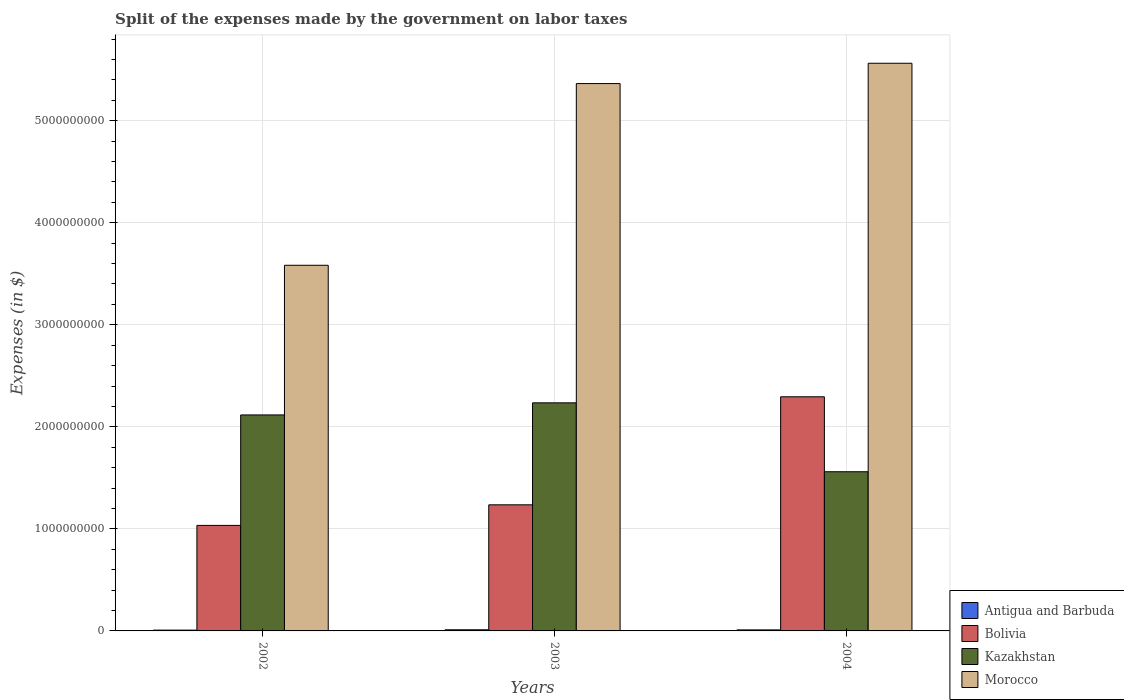Are the number of bars on each tick of the X-axis equal?
Keep it short and to the point. Yes. How many bars are there on the 2nd tick from the left?
Your response must be concise. 4. What is the label of the 3rd group of bars from the left?
Your answer should be very brief. 2004. In how many cases, is the number of bars for a given year not equal to the number of legend labels?
Give a very brief answer. 0. What is the expenses made by the government on labor taxes in Bolivia in 2003?
Offer a very short reply. 1.24e+09. Across all years, what is the maximum expenses made by the government on labor taxes in Bolivia?
Give a very brief answer. 2.29e+09. Across all years, what is the minimum expenses made by the government on labor taxes in Antigua and Barbuda?
Your answer should be very brief. 7.90e+06. In which year was the expenses made by the government on labor taxes in Morocco maximum?
Offer a very short reply. 2004. What is the total expenses made by the government on labor taxes in Antigua and Barbuda in the graph?
Offer a very short reply. 2.90e+07. What is the difference between the expenses made by the government on labor taxes in Antigua and Barbuda in 2002 and that in 2003?
Your answer should be compact. -3.20e+06. What is the difference between the expenses made by the government on labor taxes in Morocco in 2003 and the expenses made by the government on labor taxes in Antigua and Barbuda in 2002?
Keep it short and to the point. 5.36e+09. What is the average expenses made by the government on labor taxes in Kazakhstan per year?
Keep it short and to the point. 1.97e+09. In the year 2003, what is the difference between the expenses made by the government on labor taxes in Kazakhstan and expenses made by the government on labor taxes in Morocco?
Offer a very short reply. -3.13e+09. In how many years, is the expenses made by the government on labor taxes in Morocco greater than 1200000000 $?
Make the answer very short. 3. What is the ratio of the expenses made by the government on labor taxes in Antigua and Barbuda in 2002 to that in 2004?
Keep it short and to the point. 0.79. Is the expenses made by the government on labor taxes in Morocco in 2002 less than that in 2003?
Make the answer very short. Yes. Is the difference between the expenses made by the government on labor taxes in Kazakhstan in 2002 and 2004 greater than the difference between the expenses made by the government on labor taxes in Morocco in 2002 and 2004?
Keep it short and to the point. Yes. What is the difference between the highest and the second highest expenses made by the government on labor taxes in Morocco?
Your answer should be very brief. 1.99e+08. What is the difference between the highest and the lowest expenses made by the government on labor taxes in Antigua and Barbuda?
Offer a terse response. 3.20e+06. Is the sum of the expenses made by the government on labor taxes in Bolivia in 2002 and 2003 greater than the maximum expenses made by the government on labor taxes in Kazakhstan across all years?
Your response must be concise. Yes. Is it the case that in every year, the sum of the expenses made by the government on labor taxes in Antigua and Barbuda and expenses made by the government on labor taxes in Kazakhstan is greater than the sum of expenses made by the government on labor taxes in Morocco and expenses made by the government on labor taxes in Bolivia?
Keep it short and to the point. No. How many bars are there?
Keep it short and to the point. 12. Are all the bars in the graph horizontal?
Your answer should be very brief. No. How many years are there in the graph?
Give a very brief answer. 3. Where does the legend appear in the graph?
Provide a short and direct response. Bottom right. What is the title of the graph?
Give a very brief answer. Split of the expenses made by the government on labor taxes. What is the label or title of the Y-axis?
Your response must be concise. Expenses (in $). What is the Expenses (in $) in Antigua and Barbuda in 2002?
Your answer should be compact. 7.90e+06. What is the Expenses (in $) of Bolivia in 2002?
Your answer should be compact. 1.03e+09. What is the Expenses (in $) of Kazakhstan in 2002?
Provide a succinct answer. 2.12e+09. What is the Expenses (in $) in Morocco in 2002?
Your answer should be compact. 3.58e+09. What is the Expenses (in $) of Antigua and Barbuda in 2003?
Your answer should be compact. 1.11e+07. What is the Expenses (in $) of Bolivia in 2003?
Your response must be concise. 1.24e+09. What is the Expenses (in $) in Kazakhstan in 2003?
Provide a succinct answer. 2.24e+09. What is the Expenses (in $) of Morocco in 2003?
Provide a short and direct response. 5.36e+09. What is the Expenses (in $) of Antigua and Barbuda in 2004?
Give a very brief answer. 1.00e+07. What is the Expenses (in $) in Bolivia in 2004?
Offer a terse response. 2.29e+09. What is the Expenses (in $) of Kazakhstan in 2004?
Keep it short and to the point. 1.56e+09. What is the Expenses (in $) of Morocco in 2004?
Your response must be concise. 5.56e+09. Across all years, what is the maximum Expenses (in $) in Antigua and Barbuda?
Ensure brevity in your answer.  1.11e+07. Across all years, what is the maximum Expenses (in $) of Bolivia?
Your answer should be compact. 2.29e+09. Across all years, what is the maximum Expenses (in $) in Kazakhstan?
Provide a succinct answer. 2.24e+09. Across all years, what is the maximum Expenses (in $) of Morocco?
Give a very brief answer. 5.56e+09. Across all years, what is the minimum Expenses (in $) of Antigua and Barbuda?
Offer a terse response. 7.90e+06. Across all years, what is the minimum Expenses (in $) of Bolivia?
Your response must be concise. 1.03e+09. Across all years, what is the minimum Expenses (in $) of Kazakhstan?
Keep it short and to the point. 1.56e+09. Across all years, what is the minimum Expenses (in $) of Morocco?
Keep it short and to the point. 3.58e+09. What is the total Expenses (in $) of Antigua and Barbuda in the graph?
Your response must be concise. 2.90e+07. What is the total Expenses (in $) in Bolivia in the graph?
Keep it short and to the point. 4.56e+09. What is the total Expenses (in $) of Kazakhstan in the graph?
Provide a short and direct response. 5.91e+09. What is the total Expenses (in $) of Morocco in the graph?
Offer a terse response. 1.45e+1. What is the difference between the Expenses (in $) in Antigua and Barbuda in 2002 and that in 2003?
Provide a succinct answer. -3.20e+06. What is the difference between the Expenses (in $) in Bolivia in 2002 and that in 2003?
Provide a succinct answer. -2.02e+08. What is the difference between the Expenses (in $) in Kazakhstan in 2002 and that in 2003?
Keep it short and to the point. -1.19e+08. What is the difference between the Expenses (in $) in Morocco in 2002 and that in 2003?
Your answer should be very brief. -1.78e+09. What is the difference between the Expenses (in $) of Antigua and Barbuda in 2002 and that in 2004?
Keep it short and to the point. -2.10e+06. What is the difference between the Expenses (in $) of Bolivia in 2002 and that in 2004?
Offer a terse response. -1.26e+09. What is the difference between the Expenses (in $) in Kazakhstan in 2002 and that in 2004?
Ensure brevity in your answer.  5.57e+08. What is the difference between the Expenses (in $) in Morocco in 2002 and that in 2004?
Give a very brief answer. -1.98e+09. What is the difference between the Expenses (in $) in Antigua and Barbuda in 2003 and that in 2004?
Provide a succinct answer. 1.10e+06. What is the difference between the Expenses (in $) of Bolivia in 2003 and that in 2004?
Give a very brief answer. -1.06e+09. What is the difference between the Expenses (in $) in Kazakhstan in 2003 and that in 2004?
Give a very brief answer. 6.75e+08. What is the difference between the Expenses (in $) in Morocco in 2003 and that in 2004?
Ensure brevity in your answer.  -1.99e+08. What is the difference between the Expenses (in $) of Antigua and Barbuda in 2002 and the Expenses (in $) of Bolivia in 2003?
Offer a very short reply. -1.23e+09. What is the difference between the Expenses (in $) of Antigua and Barbuda in 2002 and the Expenses (in $) of Kazakhstan in 2003?
Offer a very short reply. -2.23e+09. What is the difference between the Expenses (in $) of Antigua and Barbuda in 2002 and the Expenses (in $) of Morocco in 2003?
Provide a succinct answer. -5.36e+09. What is the difference between the Expenses (in $) of Bolivia in 2002 and the Expenses (in $) of Kazakhstan in 2003?
Provide a short and direct response. -1.20e+09. What is the difference between the Expenses (in $) of Bolivia in 2002 and the Expenses (in $) of Morocco in 2003?
Your response must be concise. -4.33e+09. What is the difference between the Expenses (in $) in Kazakhstan in 2002 and the Expenses (in $) in Morocco in 2003?
Make the answer very short. -3.25e+09. What is the difference between the Expenses (in $) of Antigua and Barbuda in 2002 and the Expenses (in $) of Bolivia in 2004?
Provide a short and direct response. -2.29e+09. What is the difference between the Expenses (in $) of Antigua and Barbuda in 2002 and the Expenses (in $) of Kazakhstan in 2004?
Keep it short and to the point. -1.55e+09. What is the difference between the Expenses (in $) of Antigua and Barbuda in 2002 and the Expenses (in $) of Morocco in 2004?
Ensure brevity in your answer.  -5.56e+09. What is the difference between the Expenses (in $) of Bolivia in 2002 and the Expenses (in $) of Kazakhstan in 2004?
Provide a short and direct response. -5.26e+08. What is the difference between the Expenses (in $) of Bolivia in 2002 and the Expenses (in $) of Morocco in 2004?
Keep it short and to the point. -4.53e+09. What is the difference between the Expenses (in $) in Kazakhstan in 2002 and the Expenses (in $) in Morocco in 2004?
Give a very brief answer. -3.45e+09. What is the difference between the Expenses (in $) of Antigua and Barbuda in 2003 and the Expenses (in $) of Bolivia in 2004?
Provide a succinct answer. -2.28e+09. What is the difference between the Expenses (in $) of Antigua and Barbuda in 2003 and the Expenses (in $) of Kazakhstan in 2004?
Your answer should be compact. -1.55e+09. What is the difference between the Expenses (in $) in Antigua and Barbuda in 2003 and the Expenses (in $) in Morocco in 2004?
Your answer should be compact. -5.55e+09. What is the difference between the Expenses (in $) in Bolivia in 2003 and the Expenses (in $) in Kazakhstan in 2004?
Keep it short and to the point. -3.24e+08. What is the difference between the Expenses (in $) of Bolivia in 2003 and the Expenses (in $) of Morocco in 2004?
Give a very brief answer. -4.33e+09. What is the difference between the Expenses (in $) in Kazakhstan in 2003 and the Expenses (in $) in Morocco in 2004?
Your answer should be very brief. -3.33e+09. What is the average Expenses (in $) in Antigua and Barbuda per year?
Your response must be concise. 9.67e+06. What is the average Expenses (in $) in Bolivia per year?
Provide a short and direct response. 1.52e+09. What is the average Expenses (in $) in Kazakhstan per year?
Give a very brief answer. 1.97e+09. What is the average Expenses (in $) in Morocco per year?
Your response must be concise. 4.84e+09. In the year 2002, what is the difference between the Expenses (in $) in Antigua and Barbuda and Expenses (in $) in Bolivia?
Your answer should be compact. -1.03e+09. In the year 2002, what is the difference between the Expenses (in $) of Antigua and Barbuda and Expenses (in $) of Kazakhstan?
Provide a succinct answer. -2.11e+09. In the year 2002, what is the difference between the Expenses (in $) of Antigua and Barbuda and Expenses (in $) of Morocco?
Your answer should be compact. -3.58e+09. In the year 2002, what is the difference between the Expenses (in $) of Bolivia and Expenses (in $) of Kazakhstan?
Ensure brevity in your answer.  -1.08e+09. In the year 2002, what is the difference between the Expenses (in $) of Bolivia and Expenses (in $) of Morocco?
Your answer should be very brief. -2.55e+09. In the year 2002, what is the difference between the Expenses (in $) of Kazakhstan and Expenses (in $) of Morocco?
Give a very brief answer. -1.47e+09. In the year 2003, what is the difference between the Expenses (in $) in Antigua and Barbuda and Expenses (in $) in Bolivia?
Your answer should be very brief. -1.22e+09. In the year 2003, what is the difference between the Expenses (in $) in Antigua and Barbuda and Expenses (in $) in Kazakhstan?
Give a very brief answer. -2.22e+09. In the year 2003, what is the difference between the Expenses (in $) of Antigua and Barbuda and Expenses (in $) of Morocco?
Give a very brief answer. -5.35e+09. In the year 2003, what is the difference between the Expenses (in $) of Bolivia and Expenses (in $) of Kazakhstan?
Provide a short and direct response. -9.99e+08. In the year 2003, what is the difference between the Expenses (in $) in Bolivia and Expenses (in $) in Morocco?
Make the answer very short. -4.13e+09. In the year 2003, what is the difference between the Expenses (in $) of Kazakhstan and Expenses (in $) of Morocco?
Give a very brief answer. -3.13e+09. In the year 2004, what is the difference between the Expenses (in $) in Antigua and Barbuda and Expenses (in $) in Bolivia?
Provide a short and direct response. -2.28e+09. In the year 2004, what is the difference between the Expenses (in $) in Antigua and Barbuda and Expenses (in $) in Kazakhstan?
Offer a terse response. -1.55e+09. In the year 2004, what is the difference between the Expenses (in $) in Antigua and Barbuda and Expenses (in $) in Morocco?
Your answer should be very brief. -5.55e+09. In the year 2004, what is the difference between the Expenses (in $) of Bolivia and Expenses (in $) of Kazakhstan?
Ensure brevity in your answer.  7.35e+08. In the year 2004, what is the difference between the Expenses (in $) in Bolivia and Expenses (in $) in Morocco?
Your answer should be very brief. -3.27e+09. In the year 2004, what is the difference between the Expenses (in $) of Kazakhstan and Expenses (in $) of Morocco?
Ensure brevity in your answer.  -4.00e+09. What is the ratio of the Expenses (in $) in Antigua and Barbuda in 2002 to that in 2003?
Keep it short and to the point. 0.71. What is the ratio of the Expenses (in $) in Bolivia in 2002 to that in 2003?
Provide a short and direct response. 0.84. What is the ratio of the Expenses (in $) of Kazakhstan in 2002 to that in 2003?
Provide a succinct answer. 0.95. What is the ratio of the Expenses (in $) in Morocco in 2002 to that in 2003?
Provide a succinct answer. 0.67. What is the ratio of the Expenses (in $) of Antigua and Barbuda in 2002 to that in 2004?
Provide a succinct answer. 0.79. What is the ratio of the Expenses (in $) in Bolivia in 2002 to that in 2004?
Your response must be concise. 0.45. What is the ratio of the Expenses (in $) of Kazakhstan in 2002 to that in 2004?
Your response must be concise. 1.36. What is the ratio of the Expenses (in $) of Morocco in 2002 to that in 2004?
Provide a succinct answer. 0.64. What is the ratio of the Expenses (in $) in Antigua and Barbuda in 2003 to that in 2004?
Offer a terse response. 1.11. What is the ratio of the Expenses (in $) in Bolivia in 2003 to that in 2004?
Keep it short and to the point. 0.54. What is the ratio of the Expenses (in $) of Kazakhstan in 2003 to that in 2004?
Offer a very short reply. 1.43. What is the ratio of the Expenses (in $) of Morocco in 2003 to that in 2004?
Give a very brief answer. 0.96. What is the difference between the highest and the second highest Expenses (in $) of Antigua and Barbuda?
Offer a terse response. 1.10e+06. What is the difference between the highest and the second highest Expenses (in $) of Bolivia?
Your answer should be compact. 1.06e+09. What is the difference between the highest and the second highest Expenses (in $) of Kazakhstan?
Your response must be concise. 1.19e+08. What is the difference between the highest and the second highest Expenses (in $) in Morocco?
Provide a short and direct response. 1.99e+08. What is the difference between the highest and the lowest Expenses (in $) in Antigua and Barbuda?
Offer a very short reply. 3.20e+06. What is the difference between the highest and the lowest Expenses (in $) in Bolivia?
Your answer should be very brief. 1.26e+09. What is the difference between the highest and the lowest Expenses (in $) of Kazakhstan?
Provide a short and direct response. 6.75e+08. What is the difference between the highest and the lowest Expenses (in $) in Morocco?
Ensure brevity in your answer.  1.98e+09. 